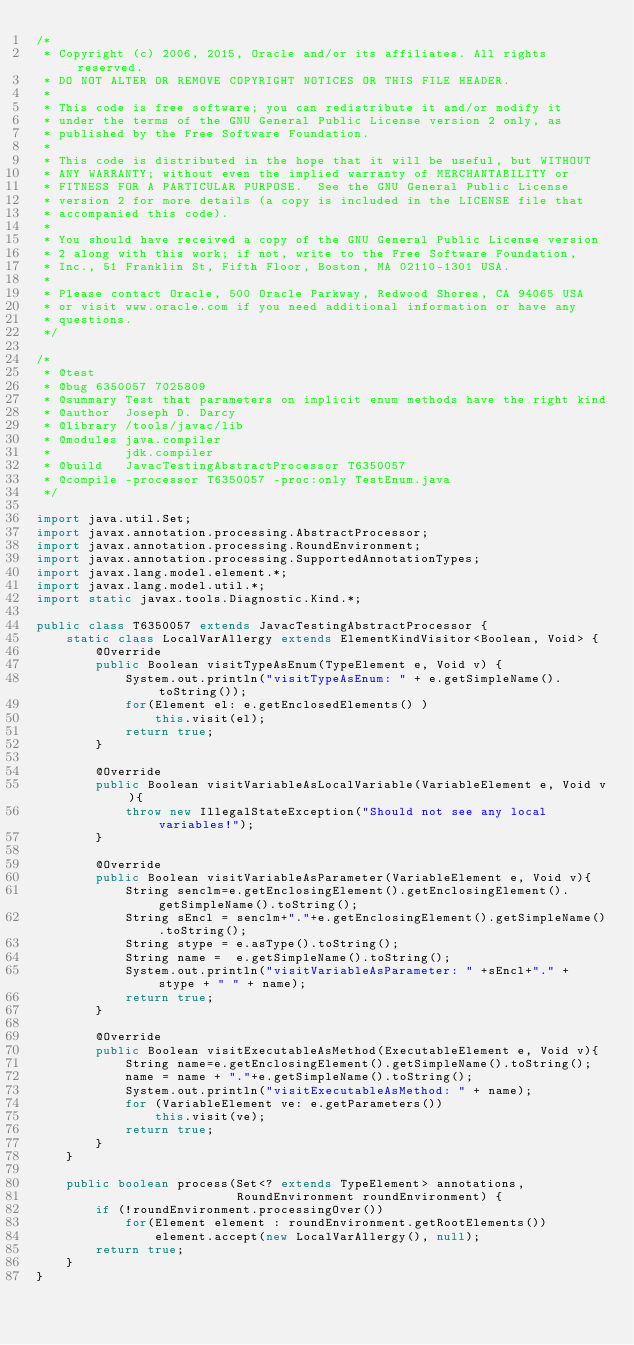Convert code to text. <code><loc_0><loc_0><loc_500><loc_500><_Java_>/*
 * Copyright (c) 2006, 2015, Oracle and/or its affiliates. All rights reserved.
 * DO NOT ALTER OR REMOVE COPYRIGHT NOTICES OR THIS FILE HEADER.
 *
 * This code is free software; you can redistribute it and/or modify it
 * under the terms of the GNU General Public License version 2 only, as
 * published by the Free Software Foundation.
 *
 * This code is distributed in the hope that it will be useful, but WITHOUT
 * ANY WARRANTY; without even the implied warranty of MERCHANTABILITY or
 * FITNESS FOR A PARTICULAR PURPOSE.  See the GNU General Public License
 * version 2 for more details (a copy is included in the LICENSE file that
 * accompanied this code).
 *
 * You should have received a copy of the GNU General Public License version
 * 2 along with this work; if not, write to the Free Software Foundation,
 * Inc., 51 Franklin St, Fifth Floor, Boston, MA 02110-1301 USA.
 *
 * Please contact Oracle, 500 Oracle Parkway, Redwood Shores, CA 94065 USA
 * or visit www.oracle.com if you need additional information or have any
 * questions.
 */

/*
 * @test
 * @bug 6350057 7025809
 * @summary Test that parameters on implicit enum methods have the right kind
 * @author  Joseph D. Darcy
 * @library /tools/javac/lib
 * @modules java.compiler
 *          jdk.compiler
 * @build   JavacTestingAbstractProcessor T6350057
 * @compile -processor T6350057 -proc:only TestEnum.java
 */

import java.util.Set;
import javax.annotation.processing.AbstractProcessor;
import javax.annotation.processing.RoundEnvironment;
import javax.annotation.processing.SupportedAnnotationTypes;
import javax.lang.model.element.*;
import javax.lang.model.util.*;
import static javax.tools.Diagnostic.Kind.*;

public class T6350057 extends JavacTestingAbstractProcessor {
    static class LocalVarAllergy extends ElementKindVisitor<Boolean, Void> {
        @Override
        public Boolean visitTypeAsEnum(TypeElement e, Void v) {
            System.out.println("visitTypeAsEnum: " + e.getSimpleName().toString());
            for(Element el: e.getEnclosedElements() )
                this.visit(el);
            return true;
        }

        @Override
        public Boolean visitVariableAsLocalVariable(VariableElement e, Void v){
            throw new IllegalStateException("Should not see any local variables!");
        }

        @Override
        public Boolean visitVariableAsParameter(VariableElement e, Void v){
            String senclm=e.getEnclosingElement().getEnclosingElement().getSimpleName().toString();
            String sEncl = senclm+"."+e.getEnclosingElement().getSimpleName().toString();
            String stype = e.asType().toString();
            String name =  e.getSimpleName().toString();
            System.out.println("visitVariableAsParameter: " +sEncl+"." + stype + " " + name);
            return true;
        }

        @Override
        public Boolean visitExecutableAsMethod(ExecutableElement e, Void v){
            String name=e.getEnclosingElement().getSimpleName().toString();
            name = name + "."+e.getSimpleName().toString();
            System.out.println("visitExecutableAsMethod: " + name);
            for (VariableElement ve: e.getParameters())
                this.visit(ve);
            return true;
        }
    }

    public boolean process(Set<? extends TypeElement> annotations,
                           RoundEnvironment roundEnvironment) {
        if (!roundEnvironment.processingOver())
            for(Element element : roundEnvironment.getRootElements())
                element.accept(new LocalVarAllergy(), null);
        return true;
    }
}
</code> 